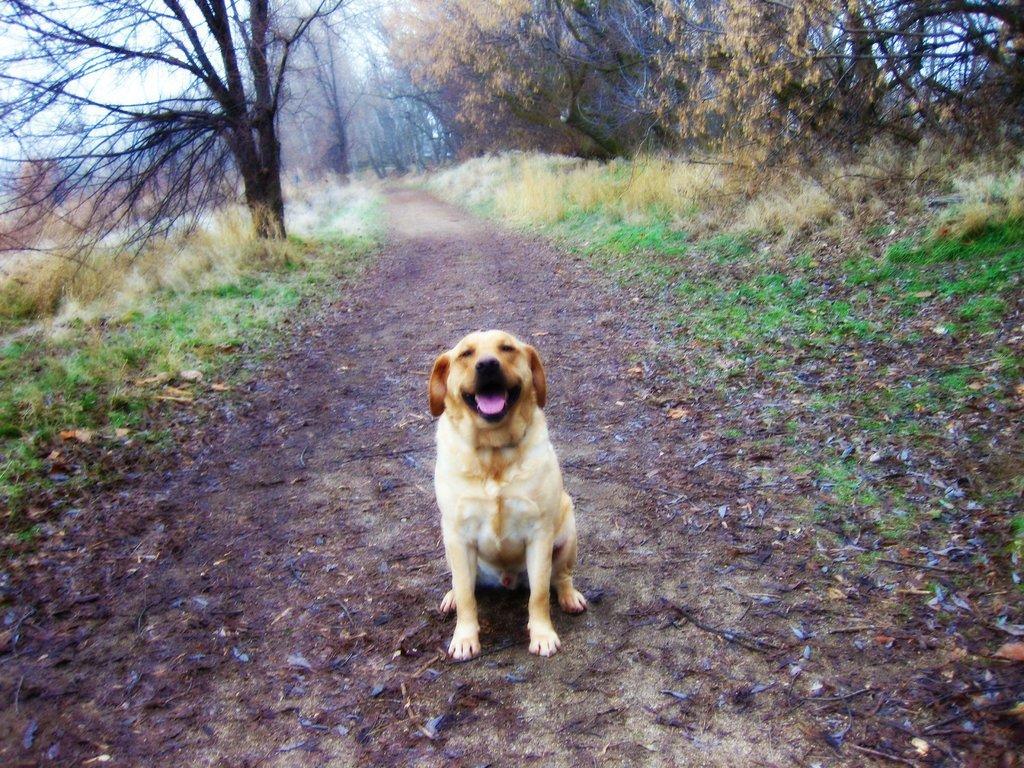How would you summarize this image in a sentence or two? In the picture we can see a pathway with a dog sitting on it and on the other sides of the path we can see a grass surface and trees and in the background also we can see trees and sky. 